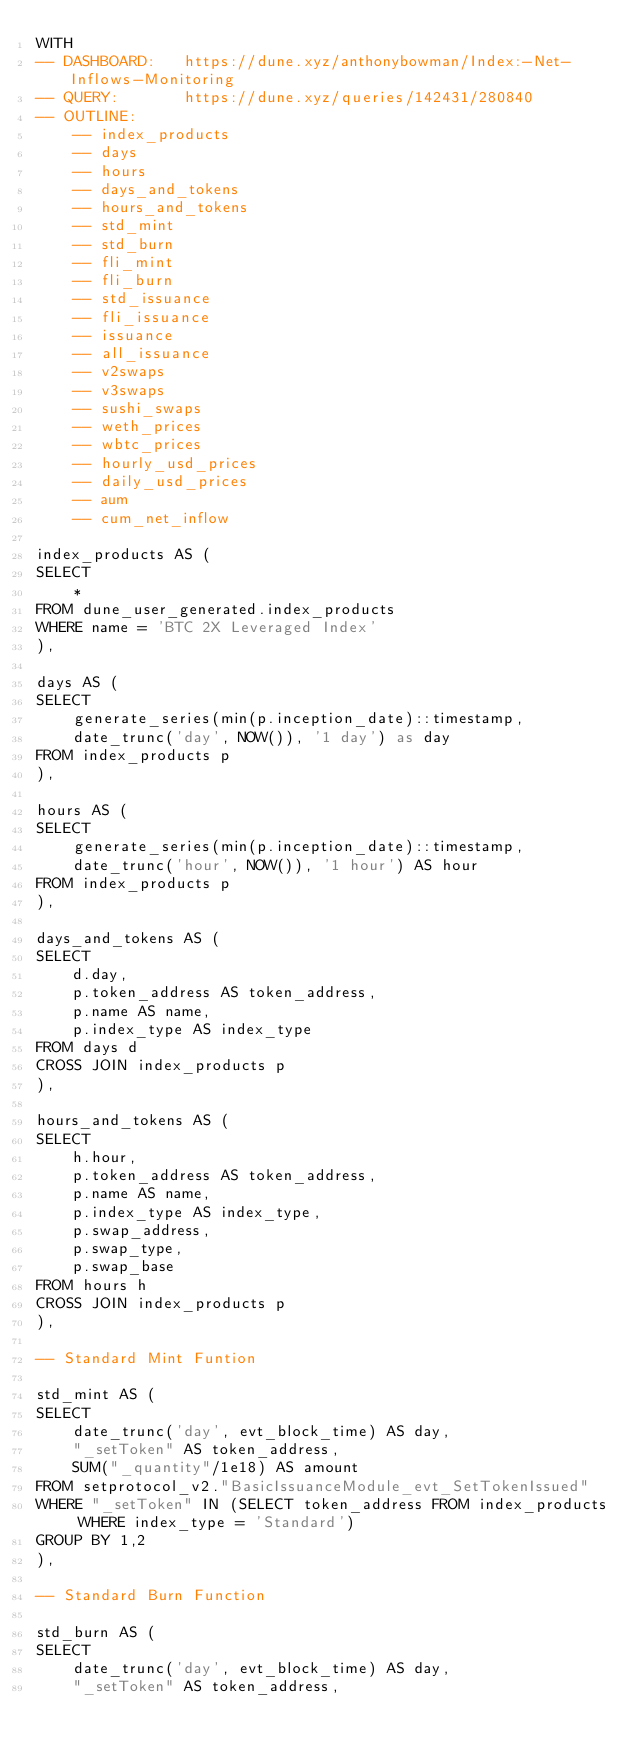Convert code to text. <code><loc_0><loc_0><loc_500><loc_500><_SQL_>WITH
-- DASHBOARD:   https://dune.xyz/anthonybowman/Index:-Net-Inflows-Monitoring
-- QUERY:       https://dune.xyz/queries/142431/280840
-- OUTLINE:
    -- index_products
    -- days
    -- hours
    -- days_and_tokens
    -- hours_and_tokens
    -- std_mint
    -- std_burn
    -- fli_mint
    -- fli_burn
    -- std_issuance
    -- fli_issuance
    -- issuance
    -- all_issuance
    -- v2swaps
    -- v3swaps
    -- sushi_swaps
    -- weth_prices
    -- wbtc_prices
    -- hourly_usd_prices
    -- daily_usd_prices
    -- aum
    -- cum_net_inflow

index_products AS (
SELECT 
    * 
FROM dune_user_generated.index_products
WHERE name = 'BTC 2X Leveraged Index'
),

days AS (
SELECT 
    generate_series(min(p.inception_date)::timestamp, 
    date_trunc('day', NOW()), '1 day') as day
FROM index_products p
),

hours AS (
SELECT
    generate_series(min(p.inception_date)::timestamp,
    date_trunc('hour', NOW()), '1 hour') AS hour
FROM index_products p
),

days_and_tokens AS (
SELECT 
    d.day,
    p.token_address AS token_address,
    p.name AS name,
    p.index_type AS index_type
FROM days d
CROSS JOIN index_products p
),

hours_and_tokens AS (
SELECT 
    h.hour,
    p.token_address AS token_address,
    p.name AS name,
    p.index_type AS index_type,
    p.swap_address,
    p.swap_type,
    p.swap_base
FROM hours h
CROSS JOIN index_products p
),

-- Standard Mint Funtion

std_mint AS (
SELECT 
    date_trunc('day', evt_block_time) AS day, 
    "_setToken" AS token_address,
    SUM("_quantity"/1e18) AS amount
FROM setprotocol_v2."BasicIssuanceModule_evt_SetTokenIssued"
WHERE "_setToken" IN (SELECT token_address FROM index_products WHERE index_type = 'Standard')
GROUP BY 1,2
),

-- Standard Burn Function

std_burn AS (
SELECT 
    date_trunc('day', evt_block_time) AS day,
    "_setToken" AS token_address,</code> 